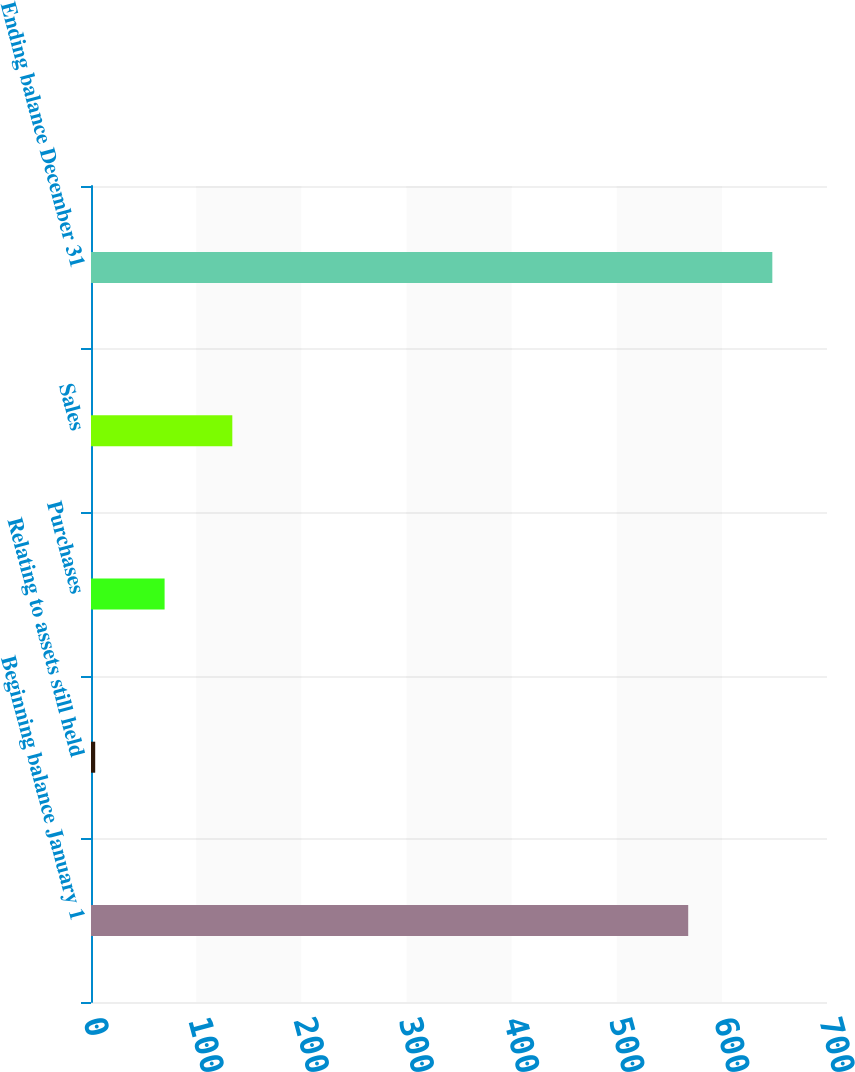<chart> <loc_0><loc_0><loc_500><loc_500><bar_chart><fcel>Beginning balance January 1<fcel>Relating to assets still held<fcel>Purchases<fcel>Sales<fcel>Ending balance December 31<nl><fcel>568<fcel>4<fcel>70<fcel>134.4<fcel>648<nl></chart> 